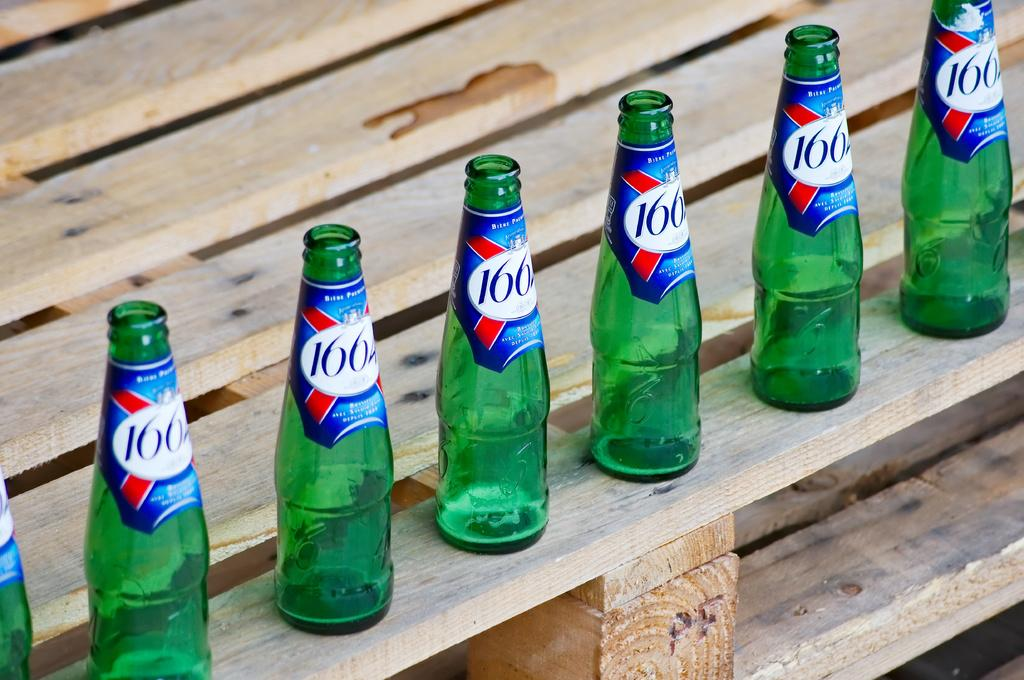<image>
Render a clear and concise summary of the photo. Various bottles labeled 1664 sit on some wood 